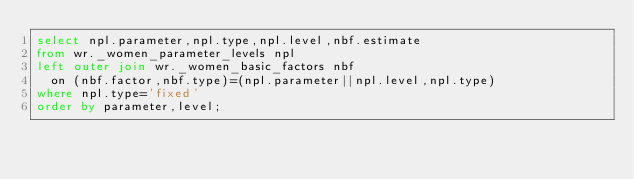<code> <loc_0><loc_0><loc_500><loc_500><_SQL_>select npl.parameter,npl.type,npl.level,nbf.estimate
from wr._women_parameter_levels npl
left outer join wr._women_basic_factors nbf
  on (nbf.factor,nbf.type)=(npl.parameter||npl.level,npl.type)
where npl.type='fixed'
order by parameter,level;
</code> 